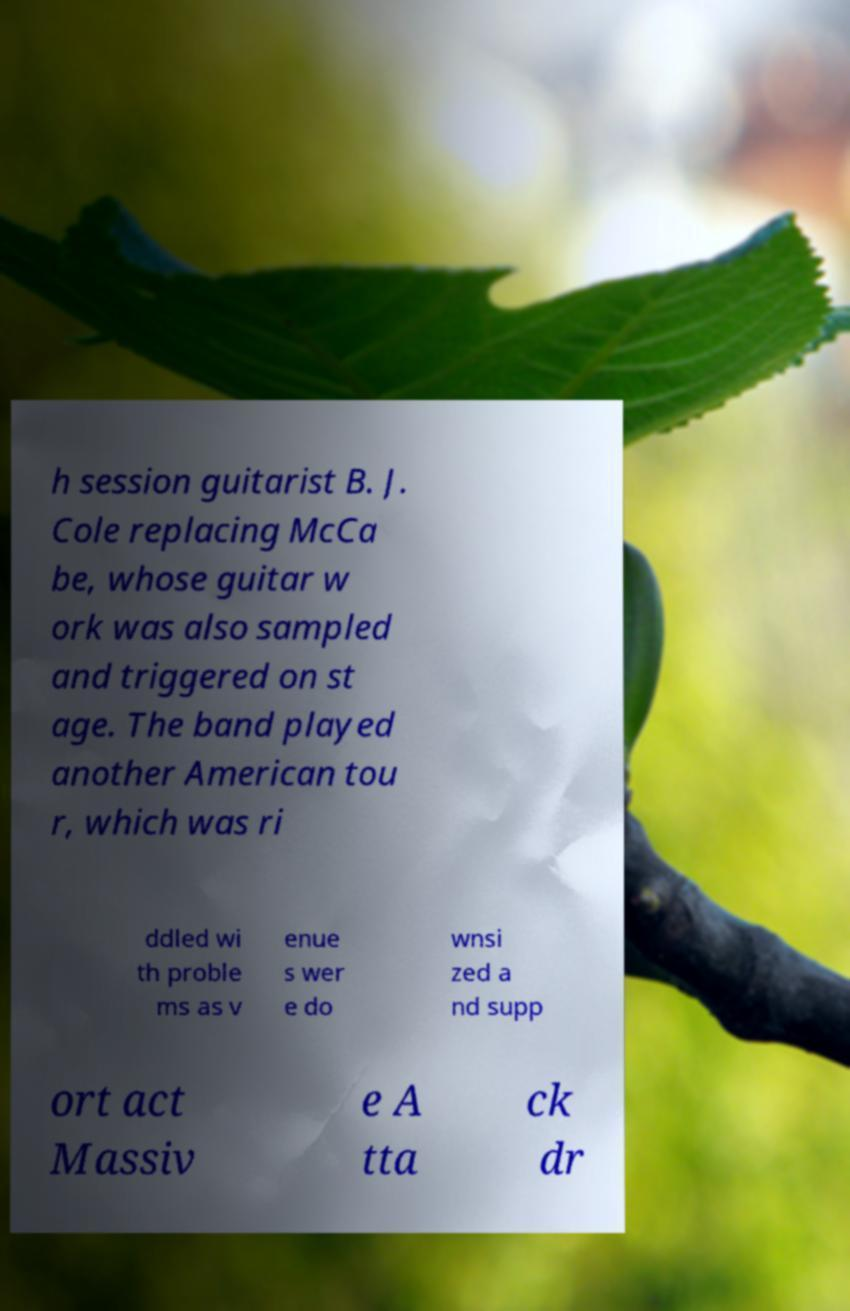Could you extract and type out the text from this image? h session guitarist B. J. Cole replacing McCa be, whose guitar w ork was also sampled and triggered on st age. The band played another American tou r, which was ri ddled wi th proble ms as v enue s wer e do wnsi zed a nd supp ort act Massiv e A tta ck dr 